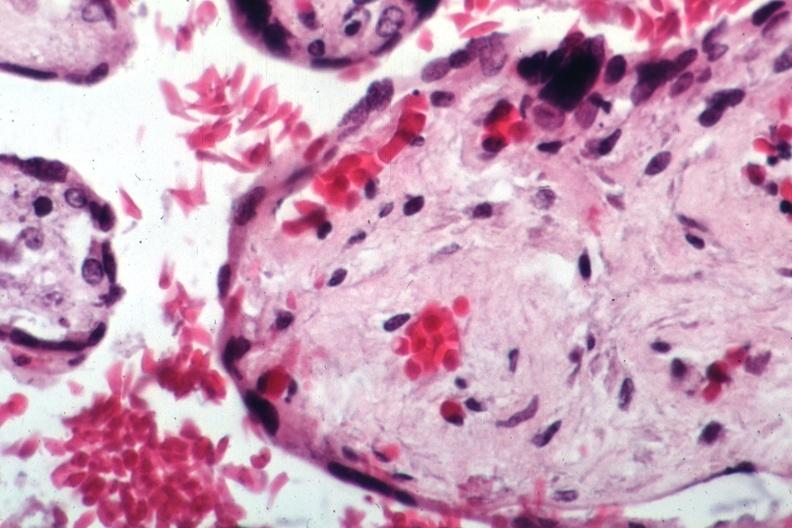s sickle cell disease present?
Answer the question using a single word or phrase. Yes 